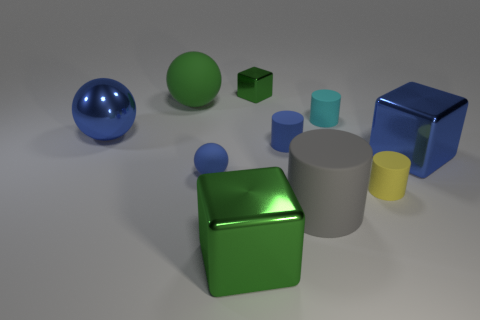Is there a cyan matte cylinder of the same size as the yellow matte cylinder?
Make the answer very short. Yes. Is the small yellow object the same shape as the gray thing?
Provide a succinct answer. Yes. Is there a gray matte object to the right of the object that is behind the green matte ball on the left side of the tiny green object?
Give a very brief answer. Yes. How many other objects are the same color as the large rubber cylinder?
Offer a terse response. 0. Do the blue thing that is to the right of the big gray rubber thing and the matte cylinder that is on the right side of the cyan matte thing have the same size?
Ensure brevity in your answer.  No. Is the number of small cyan matte cylinders to the right of the yellow object the same as the number of big green rubber balls to the left of the gray cylinder?
Your answer should be very brief. No. There is a green sphere; is it the same size as the metal object behind the tiny cyan object?
Your answer should be very brief. No. What material is the big blue thing behind the blue shiny object right of the small yellow cylinder?
Make the answer very short. Metal. Are there an equal number of small blue balls behind the large gray matte thing and large matte things?
Offer a terse response. No. There is a shiny block that is in front of the small metal thing and behind the yellow thing; what is its size?
Your response must be concise. Large. 